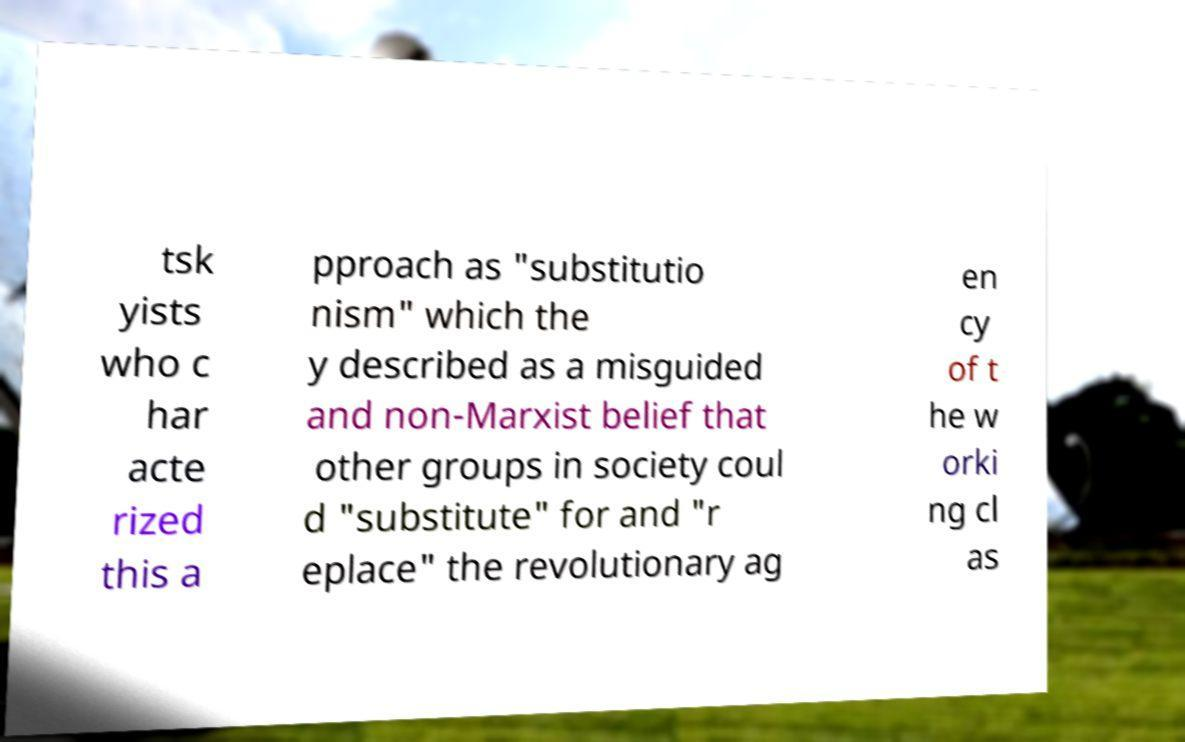Can you read and provide the text displayed in the image?This photo seems to have some interesting text. Can you extract and type it out for me? tsk yists who c har acte rized this a pproach as "substitutio nism" which the y described as a misguided and non-Marxist belief that other groups in society coul d "substitute" for and "r eplace" the revolutionary ag en cy of t he w orki ng cl as 